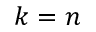<formula> <loc_0><loc_0><loc_500><loc_500>k = n</formula> 